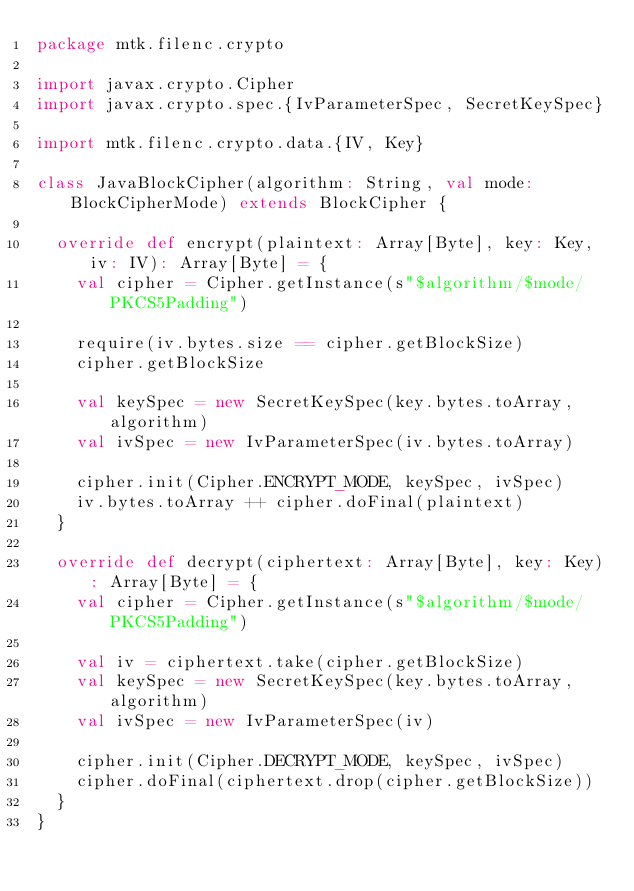Convert code to text. <code><loc_0><loc_0><loc_500><loc_500><_Scala_>package mtk.filenc.crypto

import javax.crypto.Cipher
import javax.crypto.spec.{IvParameterSpec, SecretKeySpec}

import mtk.filenc.crypto.data.{IV, Key}

class JavaBlockCipher(algorithm: String, val mode: BlockCipherMode) extends BlockCipher {

  override def encrypt(plaintext: Array[Byte], key: Key, iv: IV): Array[Byte] = {
    val cipher = Cipher.getInstance(s"$algorithm/$mode/PKCS5Padding")

    require(iv.bytes.size == cipher.getBlockSize)
    cipher.getBlockSize

    val keySpec = new SecretKeySpec(key.bytes.toArray, algorithm)
    val ivSpec = new IvParameterSpec(iv.bytes.toArray)

    cipher.init(Cipher.ENCRYPT_MODE, keySpec, ivSpec)
    iv.bytes.toArray ++ cipher.doFinal(plaintext)
  }

  override def decrypt(ciphertext: Array[Byte], key: Key): Array[Byte] = {
    val cipher = Cipher.getInstance(s"$algorithm/$mode/PKCS5Padding")

    val iv = ciphertext.take(cipher.getBlockSize)
    val keySpec = new SecretKeySpec(key.bytes.toArray, algorithm)
    val ivSpec = new IvParameterSpec(iv)

    cipher.init(Cipher.DECRYPT_MODE, keySpec, ivSpec)
    cipher.doFinal(ciphertext.drop(cipher.getBlockSize))
  }
}
</code> 